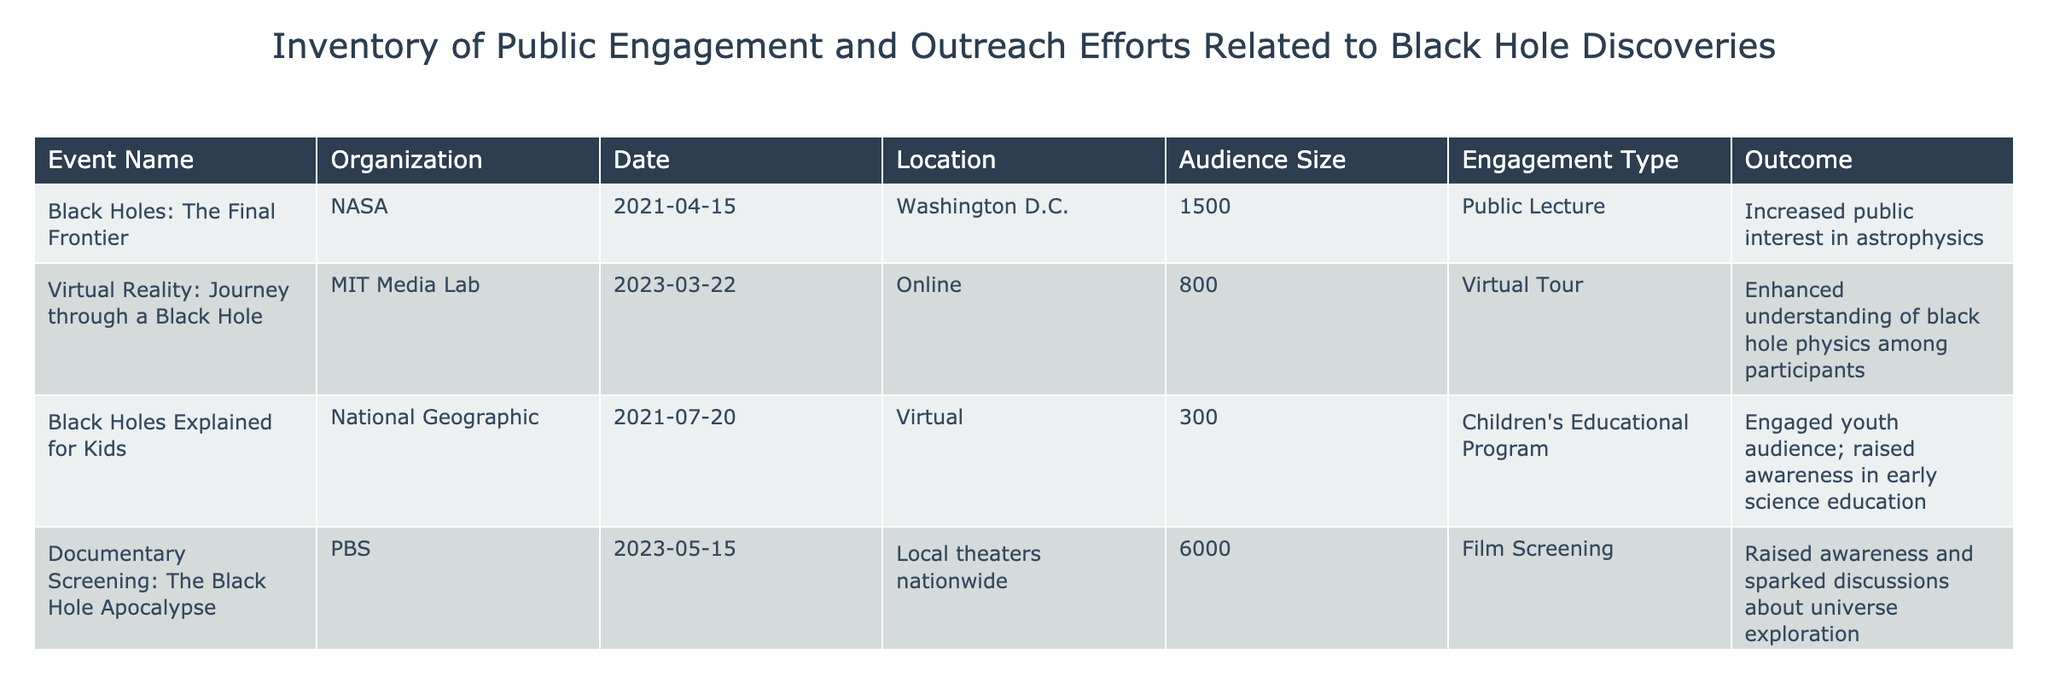What is the audience size for the event "Virtual Reality: Journey through a Black Hole"? The table lists the event "Virtual Reality: Journey through a Black Hole" under the column "Audience Size", showing a value of 800.
Answer: 800 Which organization hosted the event "Black Holes Explained for Kids"? Looking at the "Organization" column next to the event "Black Holes Explained for Kids", it is associated with "National Geographic".
Answer: National Geographic What was the engagement type for the event held on 2023-05-15? The event on this date is titled "Documentary Screening: The Black Hole Apocalypse", and its engagement type is noted as "Film Screening" in the table.
Answer: Film Screening Was there an event focused on the philosophical implications of black holes? The table contains the event "Black Holes and Philosophy", indicating it specifically explored philosophical implications, thus the answer is yes.
Answer: Yes What is the total audience size for all events listed in the table? Adding the audience sizes of all events: 1500 (NASA) + 800 (MIT Media Lab) + 300 (National Geographic) + 6000 (PBS) + 150 (Philosophy Today) results in a total of 6950.
Answer: 6950 Which event had the highest audience size? Examining the "Audience Size" values, the event "Documentary Screening: The Black Hole Apocalypse" has the largest audience of 6000, compared to other events.
Answer: Documentary Screening: The Black Hole Apocalypse What percentage of the total audience does the event "Black Holes: The Final Frontier" account for? The audience size of "Black Holes: The Final Frontier" is 1500. The total audience is 6950. To find the percentage, calculate (1500 / 6950) * 100 ≈ 21.57%, meaning it accounts for approximately 21.57%.
Answer: Approximately 21.57% Did the events increase public interest in astrophysics or raise awareness in science education? The outcomes of "Black Holes: The Final Frontier" and "Black Holes Explained for Kids" specifically mention increased public interest and raised awareness, indicating both outcomes serve this purpose.
Answer: Yes How many events were held online? By counting the events labeled as "Online" in the "Location" column, we find there are three: "Virtual Reality: Journey through a Black Hole", "Black Holes and Philosophy", and the children's program leading to a total of 3.
Answer: 3 